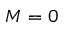Convert formula to latex. <formula><loc_0><loc_0><loc_500><loc_500>M = 0</formula> 